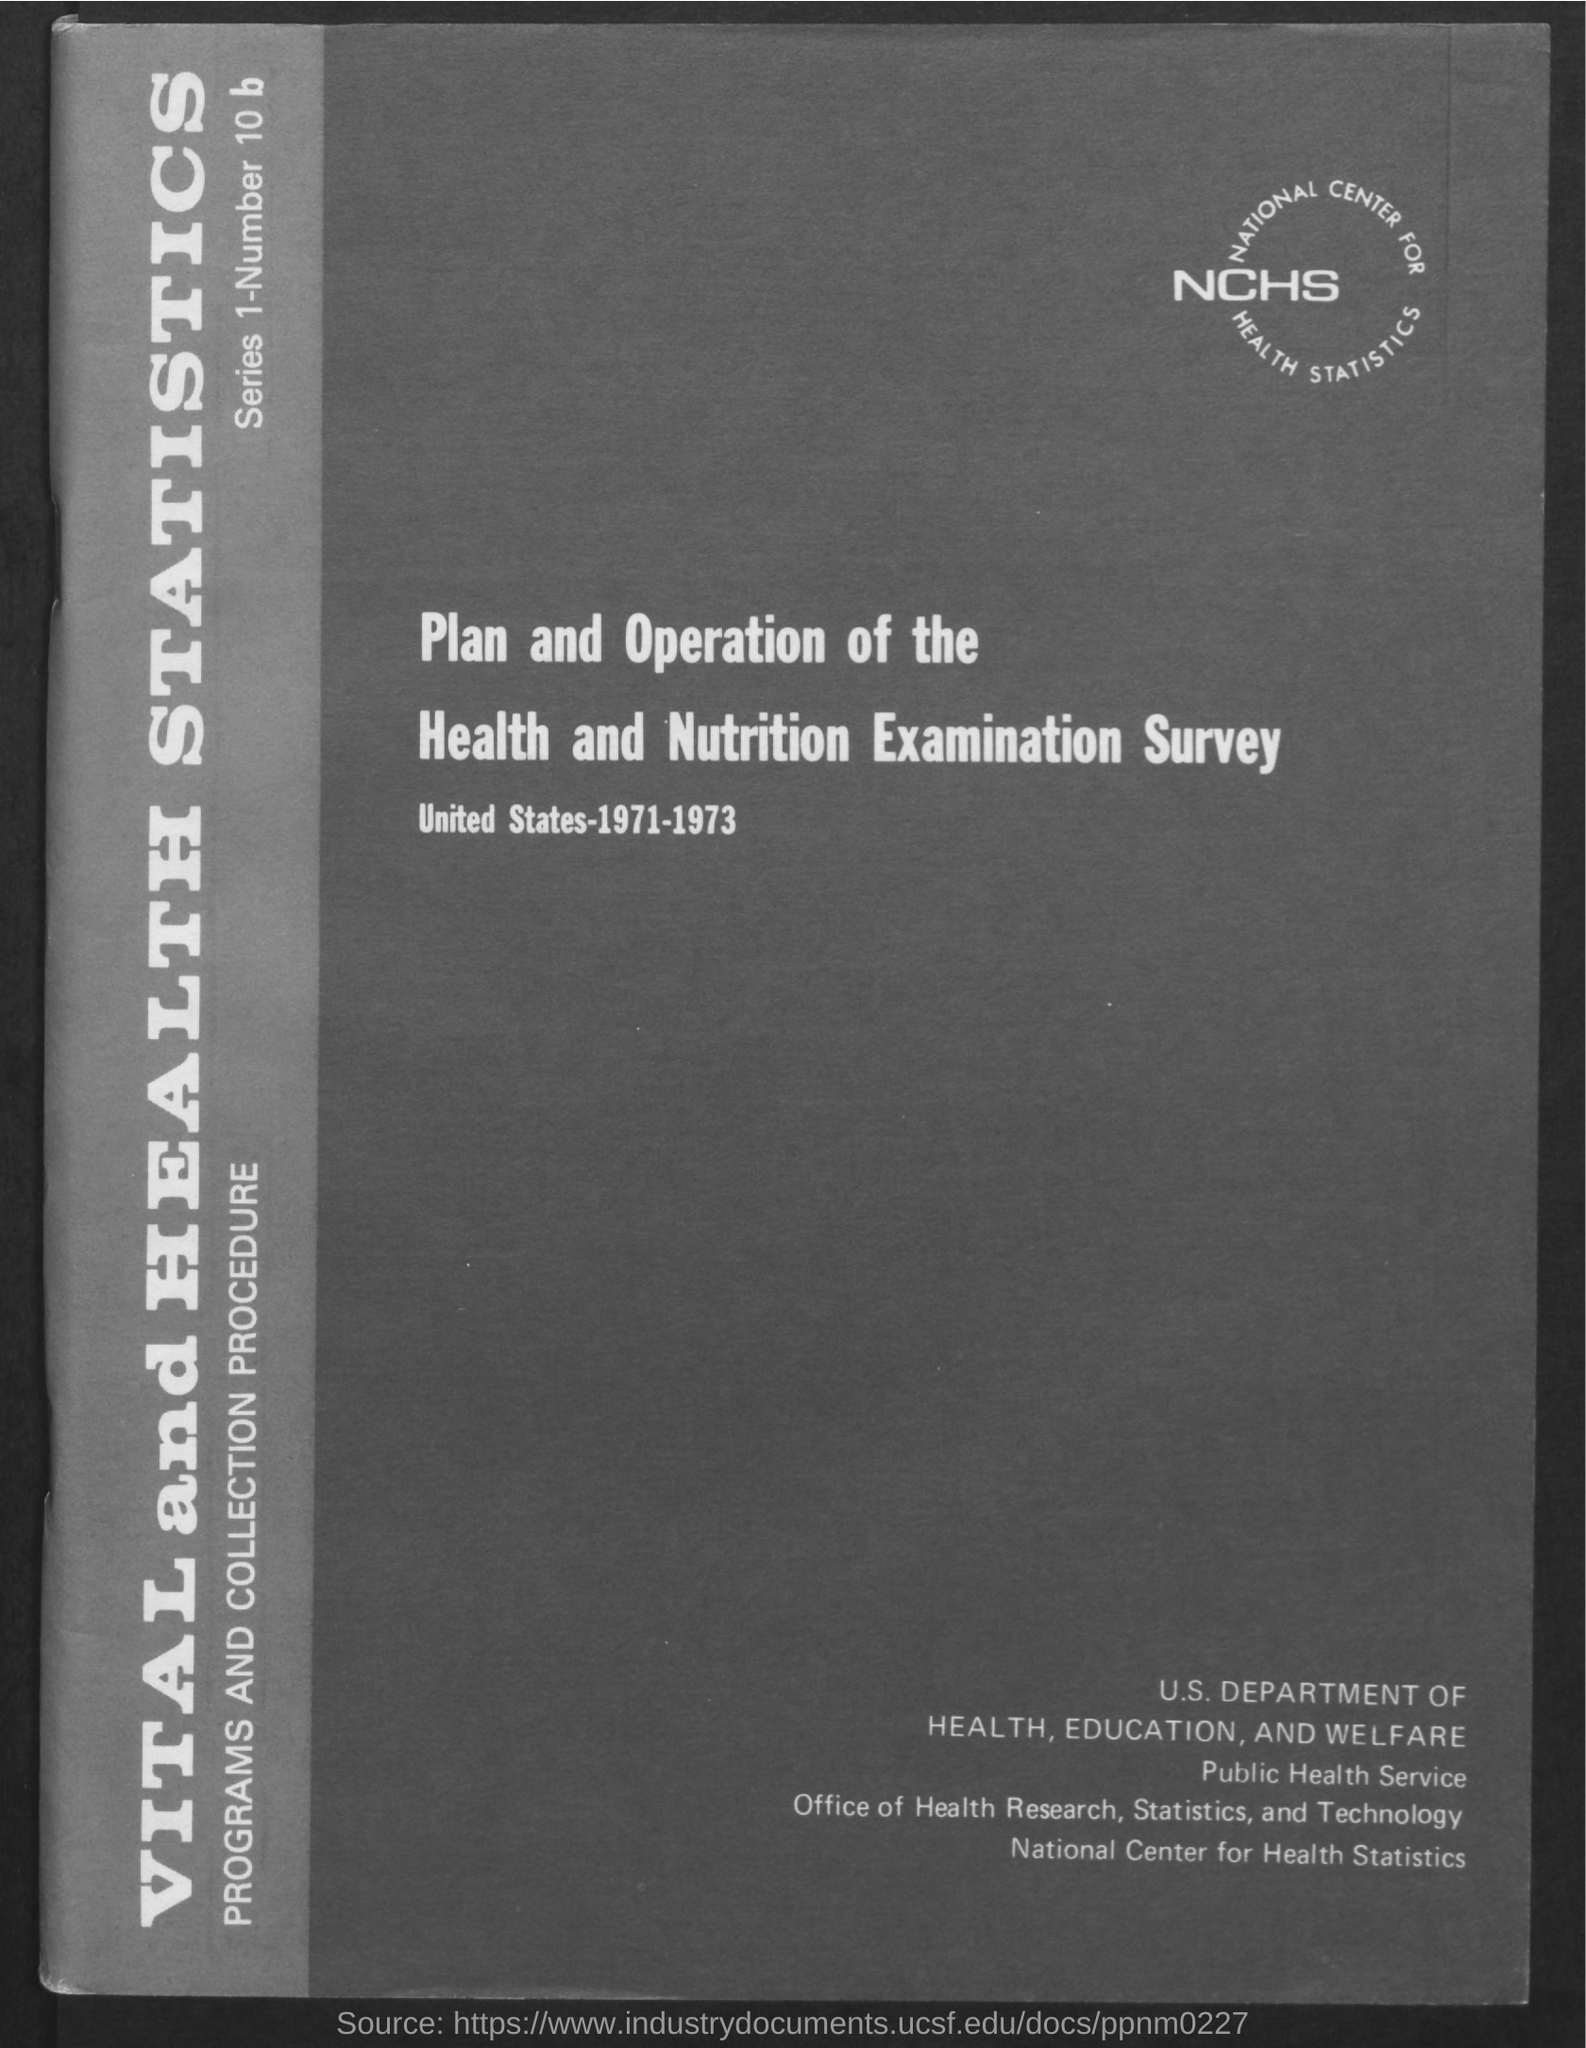What is the full form of nchs ?
Your answer should be very brief. National center for health statistics. 